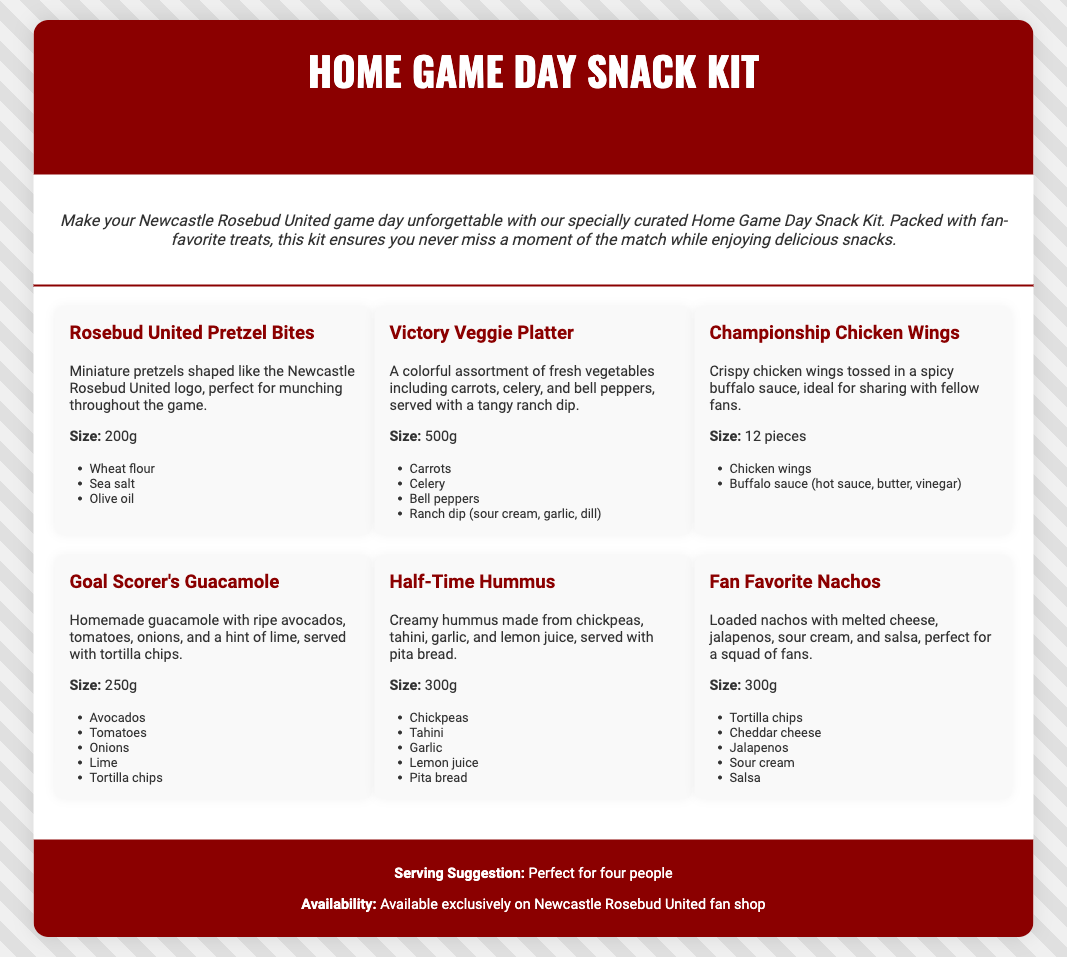what is the weight of the Rosebud United Pretzel Bites? The weight mentioned for Rosebud United Pretzel Bites is 200g.
Answer: 200g how many pieces are in the Championship Chicken Wings? The document states that the Championship Chicken Wings come in 12 pieces.
Answer: 12 pieces what is included in the Goal Scorer's Guacamole? The ingredients listed for Goal Scorer's Guacamole are avocados, tomatoes, onions, lime, and tortilla chips.
Answer: Avocados, tomatoes, onions, lime, tortilla chips what is the size of the Victory Veggie Platter? The size of the Victory Veggie Platter indicated in the document is 500g.
Answer: 500g what is the serving suggestion for the snack kit? The serving suggestion mentioned in the document states it is perfect for four people.
Answer: Four people which snack is described as "Creamy hummus made from chickpeas"? The snack described as "Creamy hummus made from chickpeas" is Half-Time Hummus.
Answer: Half-Time Hummus where can the Home Game Day Snack Kit be purchased? The document specifies that the Home Game Day Snack Kit is available exclusively in the Newcastle Rosebud United fan shop.
Answer: Newcastle Rosebud United fan shop what type of dip is served with the Victory Veggie Platter? The dip served with the Victory Veggie Platter is a tangy ranch dip.
Answer: Tangy ranch dip 